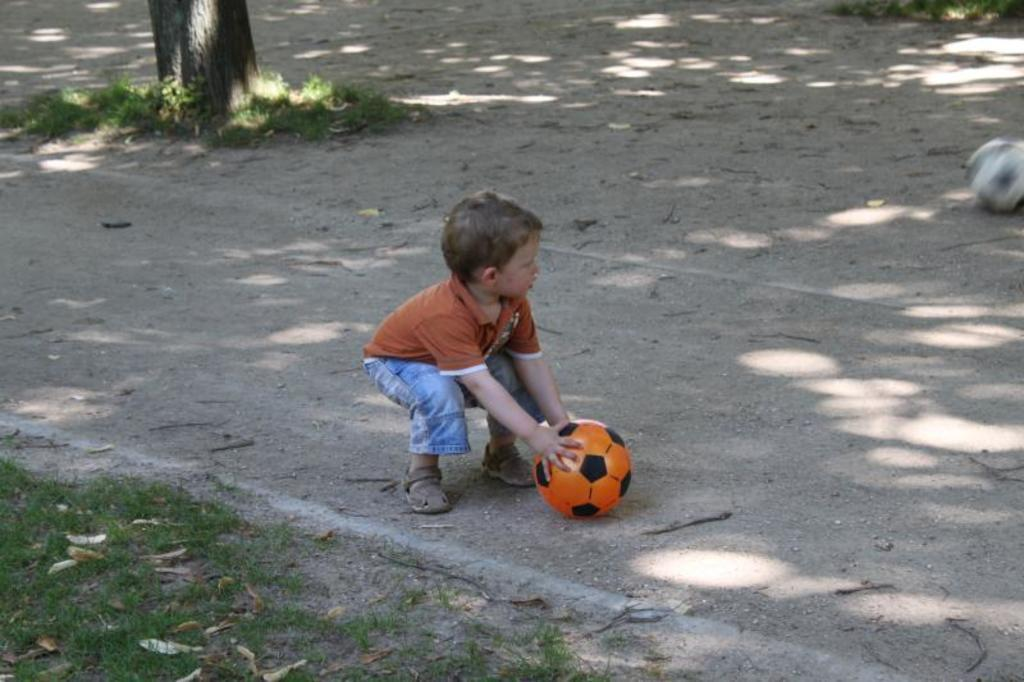Who is in the image? There is a boy in the image. What is the boy holding? The boy is holding an orange and black ball. What color is the boy's t-shirt? The boy is wearing an orange t-shirt. What type of pants is the boy wearing? The boy is wearing jeans. What can be seen in the background of the image? There is a tree trunk and grass in the background of the image. What type of lip balm is the boy applying in the image? There is no lip balm or any indication of the boy applying anything in the image. 